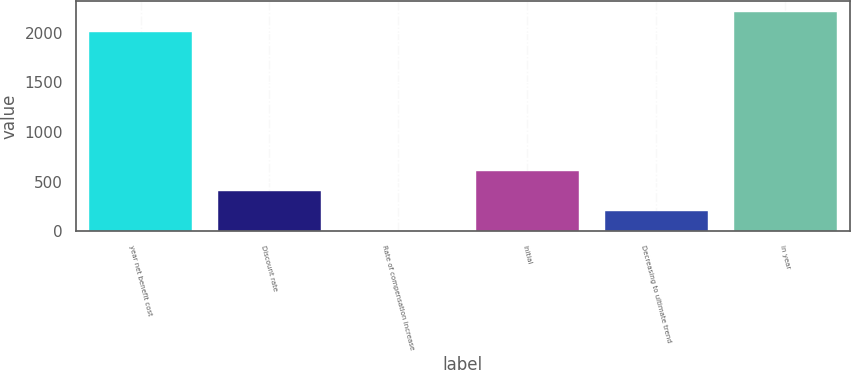Convert chart to OTSL. <chart><loc_0><loc_0><loc_500><loc_500><bar_chart><fcel>year net benefit cost<fcel>Discount rate<fcel>Rate of compensation increase<fcel>Initial<fcel>Decreasing to ultimate trend<fcel>in year<nl><fcel>2007<fcel>405.21<fcel>3.75<fcel>605.93<fcel>204.48<fcel>2207.72<nl></chart> 